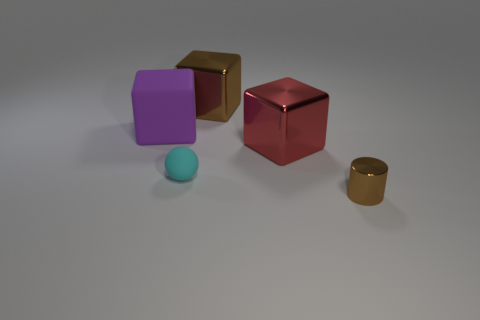Add 2 tiny yellow cylinders. How many objects exist? 7 Subtract all cubes. How many objects are left? 2 Add 5 red metal objects. How many red metal objects exist? 6 Subtract 1 purple blocks. How many objects are left? 4 Subtract all big purple rubber cubes. Subtract all red blocks. How many objects are left? 3 Add 1 purple matte things. How many purple matte things are left? 2 